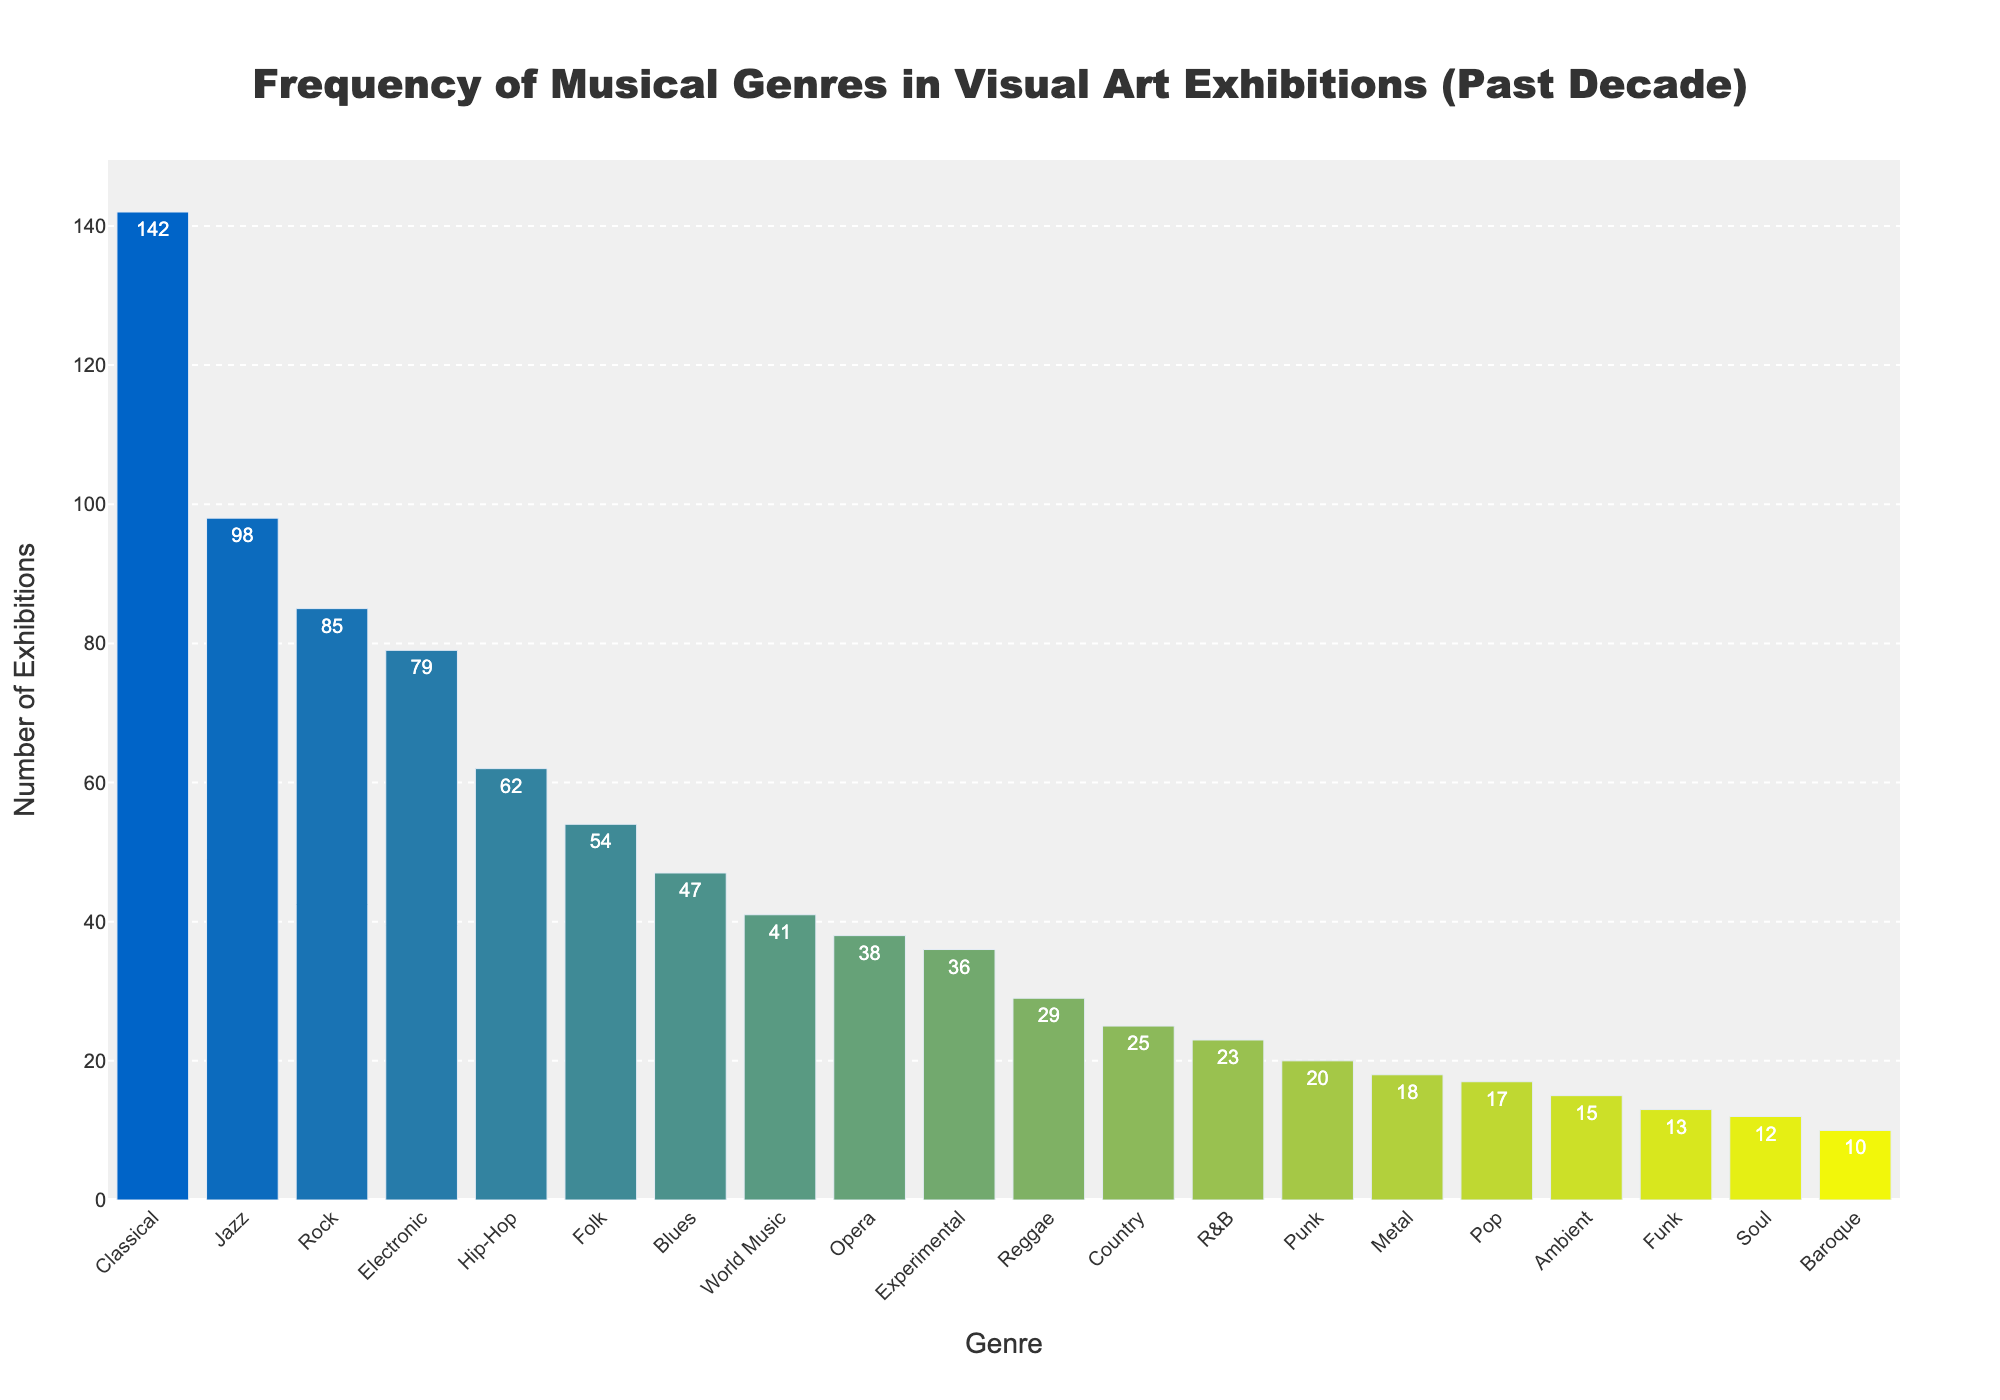Which musical genre has the highest number of exhibitions? Identify the bar with the greatest height on the chart, which represents the number of exhibitions.
Answer: Classical How many more exhibitions does Classical music have compared to Reggae? Determine the difference between the number of exhibitions for Classical (142) and Reggae (29). 142 - 29 = 113
Answer: 113 What is the total number of exhibitions for Jazz, Rock, and Electronic genres combined? Add the number of exhibitions for Jazz (98), Rock (85), and Electronic (79). 98 + 85 + 79 = 262
Answer: 262 Which genre has the least number of exhibitions, and how many does it have? Identify the bar with the lowest height on the chart, which represents the genre with the least exhibitions.
Answer: Baroque, 10 How many genres had more than 50 exhibitions? Count the number of bars whose heights (number of exhibitions) are greater than 50 on the chart.
Answer: 6 Are there more exhibitions featuring Folk music or Hip-Hop music, and by how many? Compare the number of exhibitions for Folk (54) and Hip-Hop (62). 62 - 54 = 8
Answer: Hip-Hop, 8 What is the average number of exhibitions for the top five musical genres? Take the sum of the top five exhibition counts and divide by five. (142 + 98 + 85 + 79 + 62) / 5 = 466 / 5 = 93.2
Answer: 93.2 How many genres have fewer than 20 exhibitions? Count the number of genres (bars) with fewer than 20 exhibitions.
Answer: 5 What's the difference in the number of exhibitions between the genre with the second highest and the third highest exhibitions? Identify the second and third highest values (98 for Jazz, 85 for Rock) and find the difference. 98 - 85 = 13
Answer: 13 Which genre in the middle of the sorted list by height has how many exhibitions? Find the median genre in the sorted list of exhibitions. It's the one with the 10th highest value: Experimental (36).
Answer: Experimental, 36 